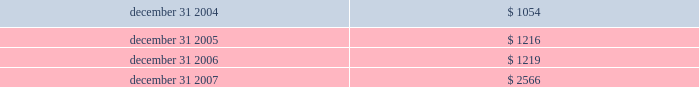Certain options to purchase shares of devon 2019s common stock were excluded from the dilution calculations because the options were antidilutive .
These excluded options totaled 2 million , 3 million and 0.2 million in 2007 , 2006 and 2005 , respectively .
Foreign currency translation adjustments the u.s .
Dollar is the functional currency for devon 2019s consolidated operations except its canadian subsidiaries , which use the canadian dollar as the functional currency .
Therefore , the assets and liabilities of devon 2019s canadian subsidiaries are translated into u.s .
Dollars based on the current exchange rate in effect at the balance sheet dates .
Canadian income and expenses are translated at average rates for the periods presented .
Translation adjustments have no effect on net income and are included in accumulated other comprehensive income in stockholders 2019 equity .
The table presents the balances of devon 2019s cumulative translation adjustments included in accumulated other comprehensive income ( in millions ) . .
Statements of cash flows for purposes of the consolidated statements of cash flows , devon considers all highly liquid investments with original contractual maturities of three months or less to be cash equivalents .
Commitments and contingencies liabilities for loss contingencies arising from claims , assessments , litigation or other sources are recorded when it is probable that a liability has been incurred and the amount can be reasonably estimated .
Liabilities for environmental remediation or restoration claims are recorded when it is probable that obligations have been incurred and the amounts can be reasonably estimated .
Expenditures related to such environmental matters are expensed or capitalized in accordance with devon 2019s accounting policy for property and equipment .
Reference is made to note 8 for a discussion of amounts recorded for these liabilities .
Recently issued accounting standards not yet adopted in december 2007 , the financial accounting standards board ( 201cfasb 201d ) issued statement of financial accounting standards no .
141 ( r ) , business combinations , which replaces statement no .
141 .
Statement no .
141 ( r ) retains the fundamental requirements of statement no .
141 that an acquirer be identified and the acquisition method of accounting ( previously called the purchase method ) be used for all business combinations .
Statement no .
141 ( r ) 2019s scope is broader than that of statement no .
141 , which applied only to business combinations in which control was obtained by transferring consideration .
By applying the acquisition method to all transactions and other events in which one entity obtains control over one or more other businesses , statement no .
141 ( r ) improves the comparability of the information about business combinations provided in financial reports .
Statement no .
141 ( r ) establishes principles and requirements for how an acquirer recognizes and measures identifiable assets acquired , liabilities assumed and any noncontrolling interest in the acquiree , as well as any resulting goodwill .
Statement no .
141 ( r ) applies prospectively to business combinations for which the acquisition date is on or after the beginning of the first annual reporting period beginning on or after december 15 , 2008 .
Devon will evaluate how the new requirements of statement no .
141 ( r ) would impact any business combinations completed in 2009 or thereafter .
In december 2007 , the fasb also issued statement of financial accounting standards no .
160 , noncontrolling interests in consolidated financial statements 2014an amendment of accounting research bulletin no .
51 .
A noncontrolling interest , sometimes called a minority interest , is the portion of equity in a subsidiary not attributable , directly or indirectly , to a parent .
Statement no .
160 establishes accounting and reporting standards for the noncontrolling interest in a subsidiary and for the deconsolidation of a subsidiary .
Under statement no .
160 , noncontrolling interests in a subsidiary must be reported as a component of consolidated equity separate from the parent 2019s equity .
Additionally , the amounts of consolidated net income attributable to both the parent and the noncontrolling interest must be reported separately on the face of the income statement .
Statement no .
160 is effective for fiscal years beginning on or after december 15 , 2008 and earlier adoption is prohibited .
Devon does not expect the adoption of statement no .
160 to have a material impact on its financial statements and related disclosures. .
What was devon's average translation adjustments included in accumulated other comprehensive income ( in millions ) from 2004 through 2007? 
Computations: ((((1054 + 1216) + 1219) + 2566) / 4)
Answer: 1513.75. 